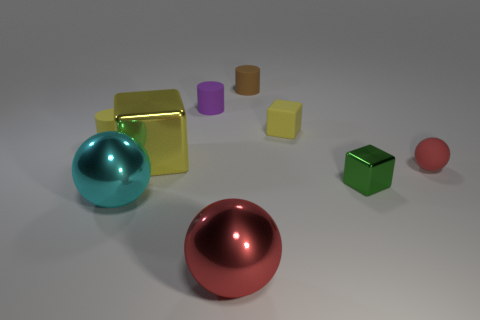Add 1 blue things. How many objects exist? 10 Subtract all spheres. How many objects are left? 6 Add 5 red metallic objects. How many red metallic objects exist? 6 Subtract 0 green cylinders. How many objects are left? 9 Subtract all tiny red balls. Subtract all tiny purple cylinders. How many objects are left? 7 Add 5 tiny yellow matte cubes. How many tiny yellow matte cubes are left? 6 